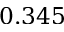Convert formula to latex. <formula><loc_0><loc_0><loc_500><loc_500>0 . 3 4 5</formula> 